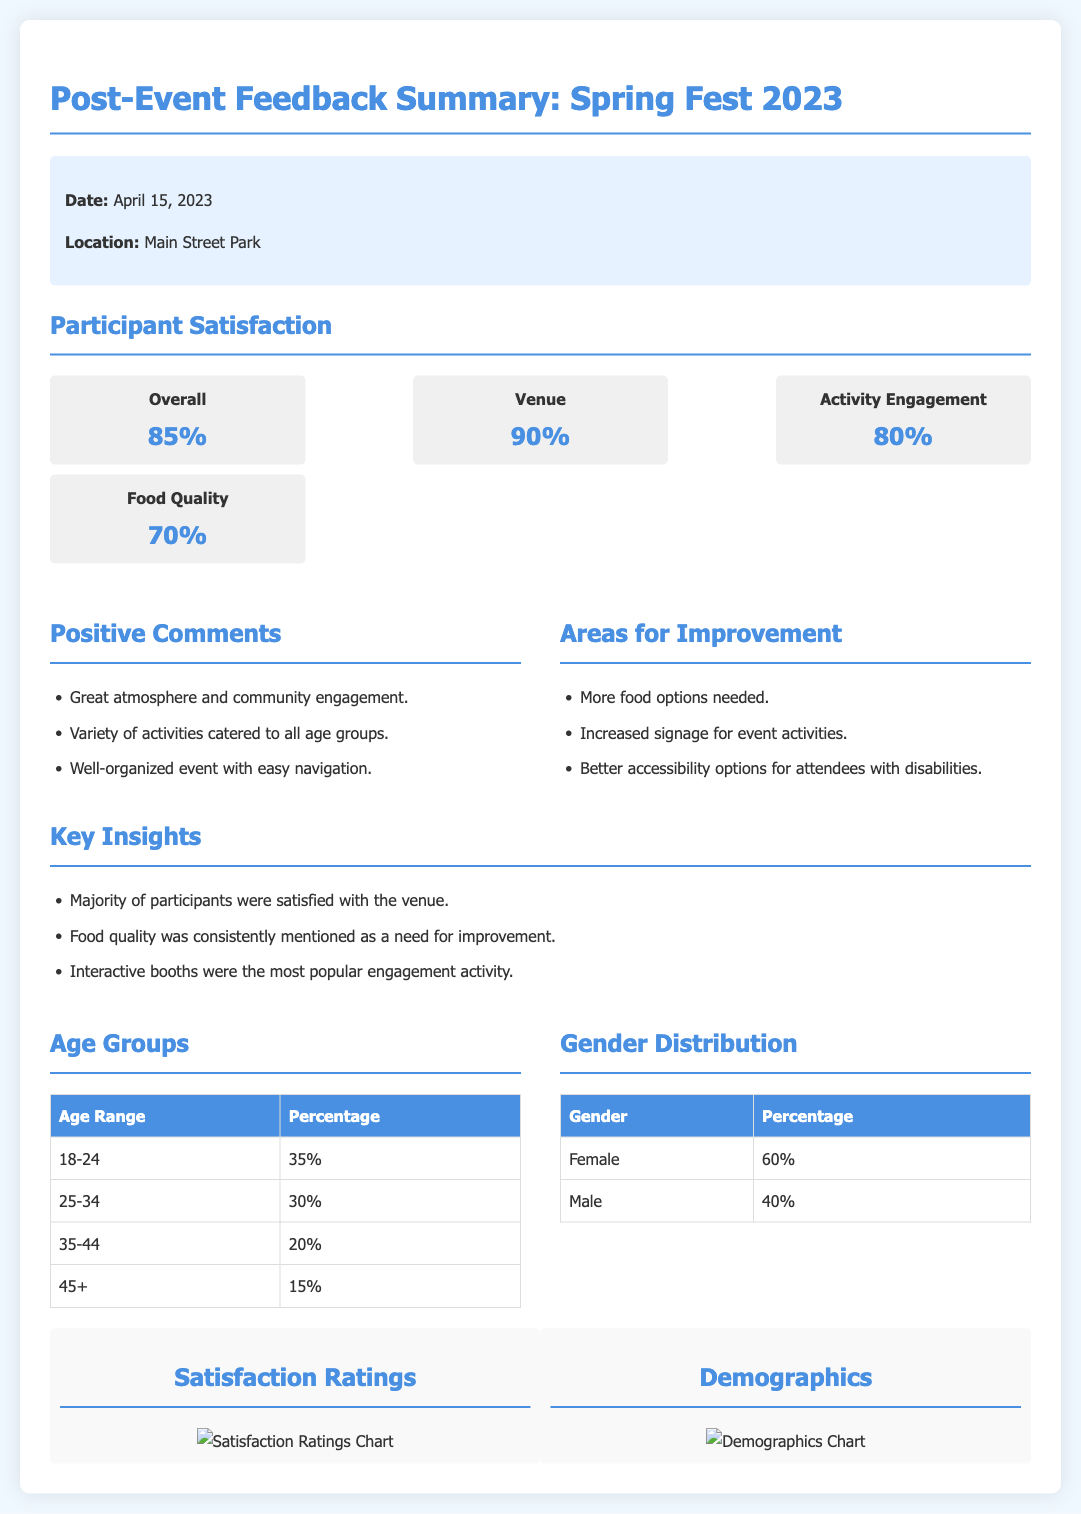What is the overall participant satisfaction rating? The overall participant satisfaction rating is listed in the satisfaction ratings section of the document.
Answer: 85% What percentage of participants rated the venue? The percentage rating of the venue is one of the overall ratings presented.
Answer: 90% What were some positive comments from participants? Positive comments are summarized in a dedicated section within the feedback.
Answer: Great atmosphere and community engagement What area was identified as needing improvement? Areas for improvement are listed in the feedback section of the document.
Answer: More food options needed What was the most popular engagement activity? This key insight is presented under the Key Insights section.
Answer: Interactive booths What is the age percentage for the age range 25-34? This data is provided in the demographics section of the document.
Answer: 30% What is the gender distribution percentage for females? The gender distribution percentages are provided in a table in the demographics section.
Answer: 60% How many age groups are represented in the age distribution table? The age distribution table shows various age ranges present at the event.
Answer: 4 What type of chart is used to represent satisfaction ratings? The type of chart is mentioned specifically in the charts section discussing satisfaction.
Answer: Pie Chart 